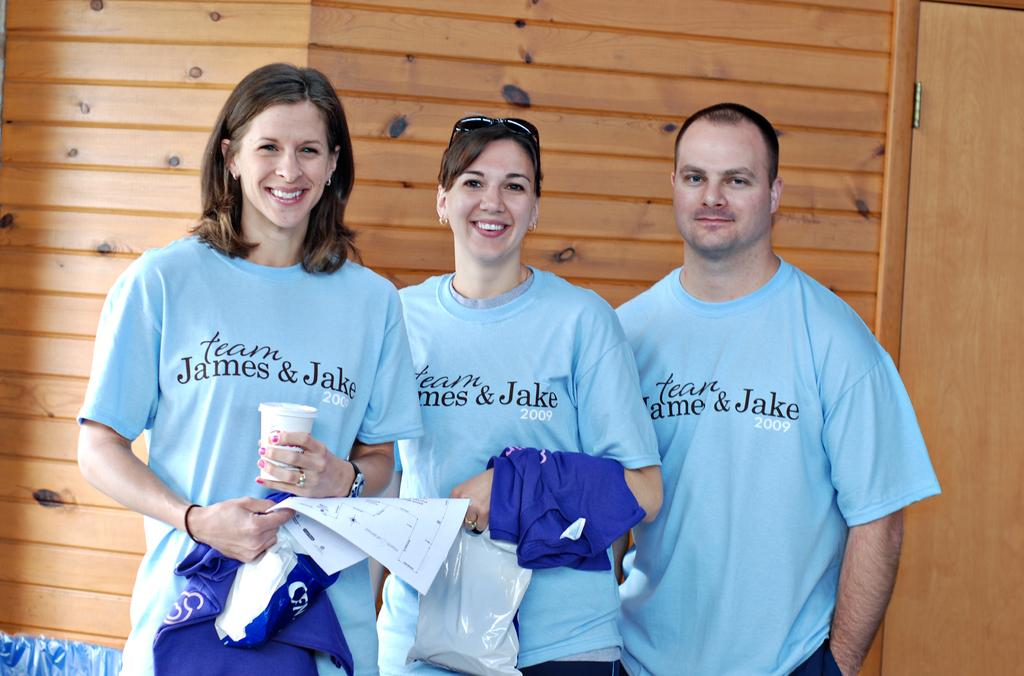What is the main subject of the image? The main subject of the image is people. What are the people doing in the image? The people are holding clothes in their hands. Can you describe any other objects or features in the image? There is a wooden door on the right side of the image. What type of base can be seen supporting the snow in the image? There is no snow or base present in the image. How does the health of the people in the image appear to be? The image does not provide any information about the health of the people. 